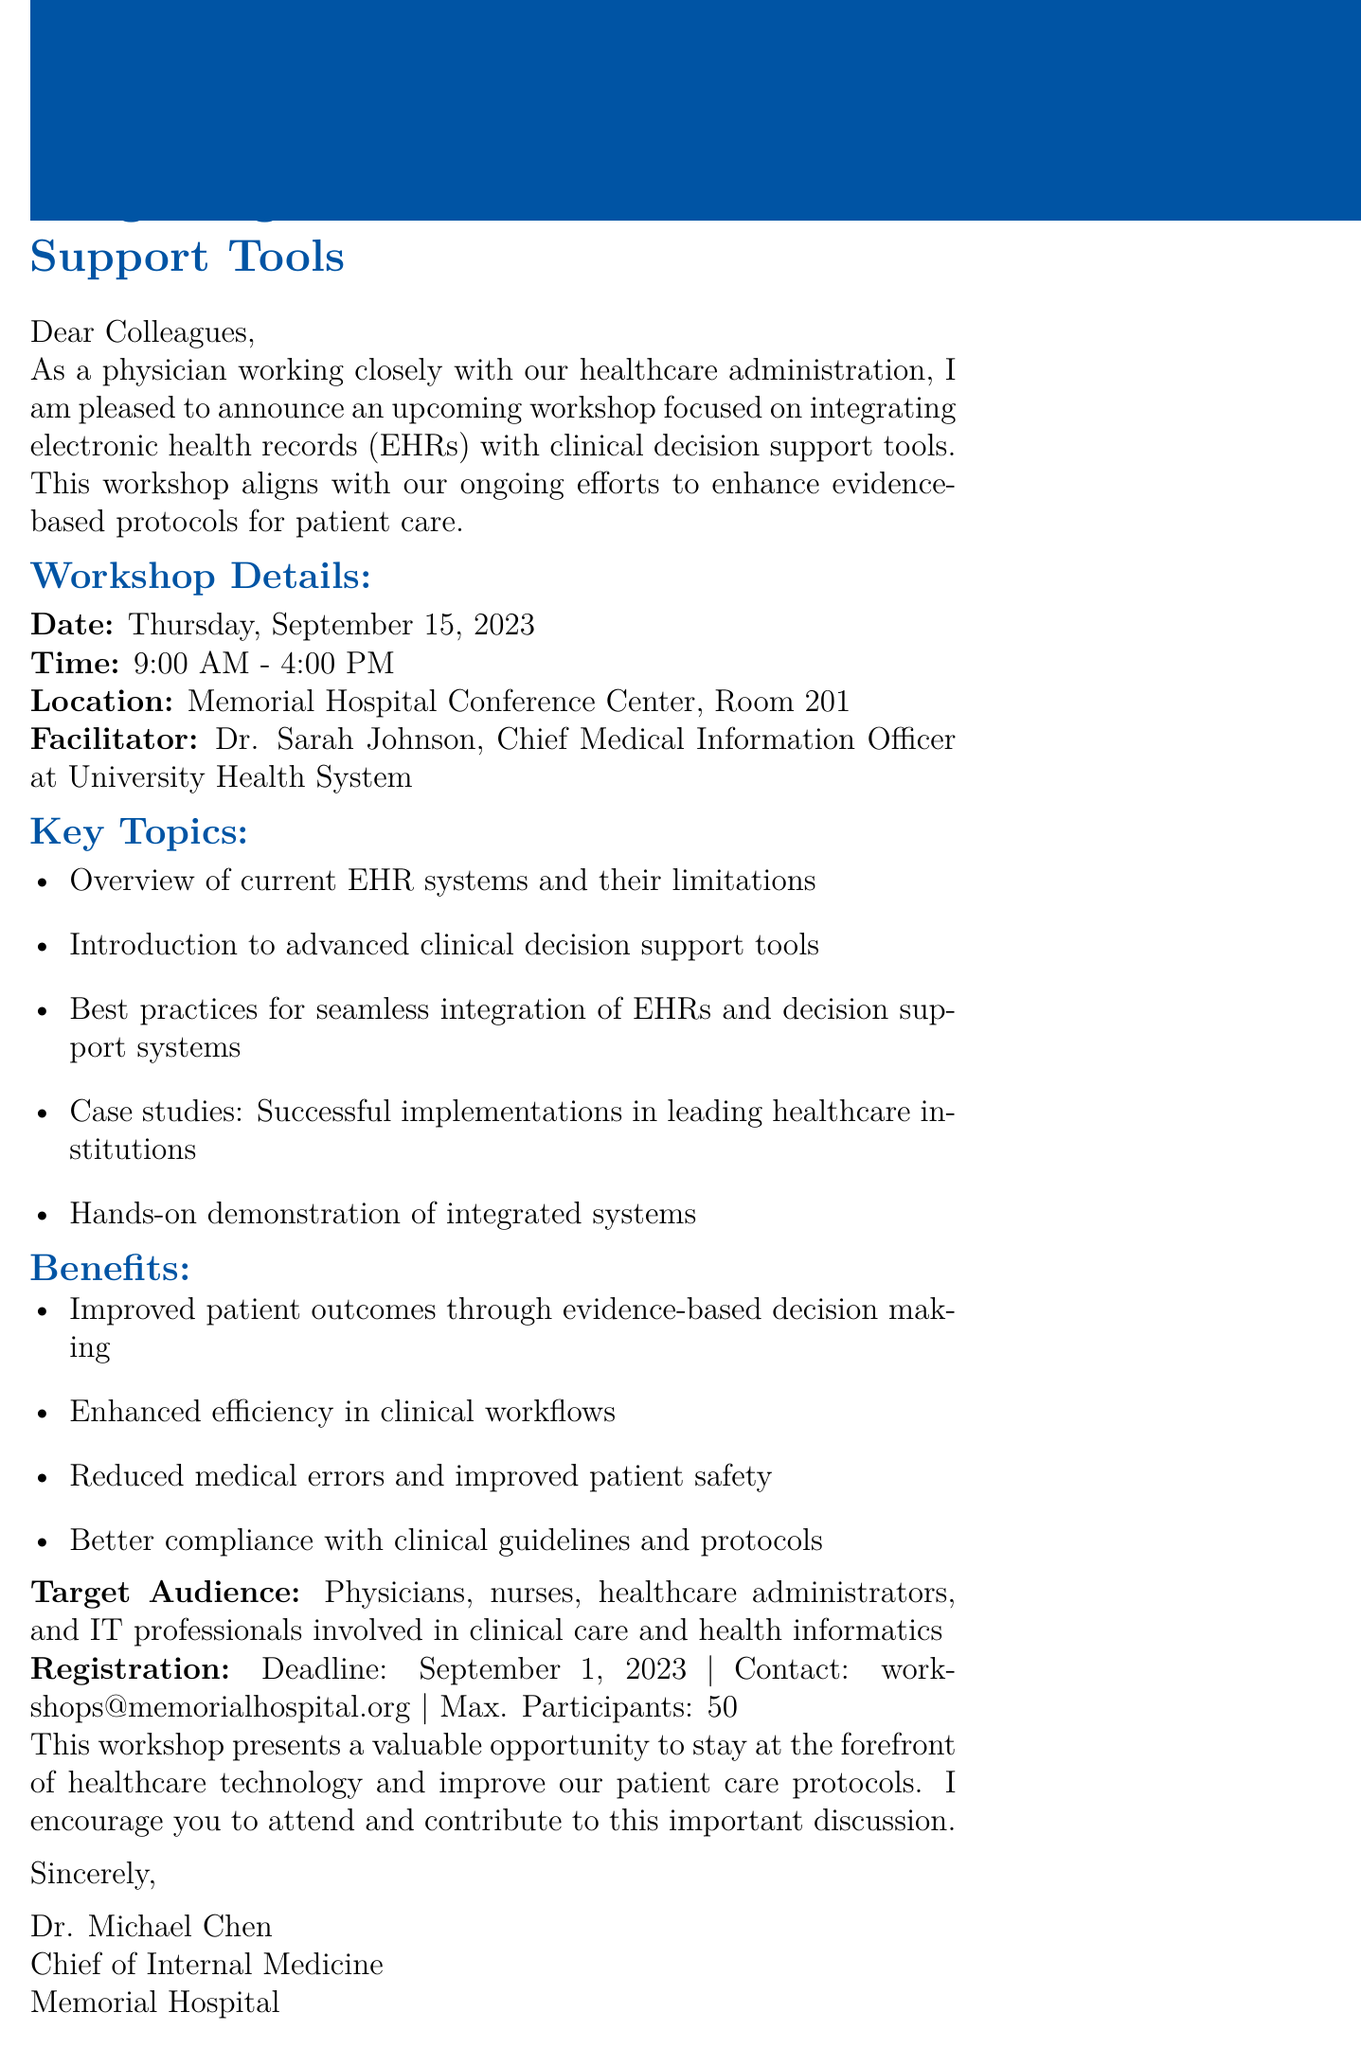What is the date of the workshop? The document specifies that the workshop will take place on Thursday, September 15, 2023.
Answer: Thursday, September 15, 2023 Who is the facilitator of the workshop? The document mentions that Dr. Sarah Johnson will be the facilitator of the workshop.
Answer: Dr. Sarah Johnson What is the maximum number of participants for the workshop? The document states that the maximum number of participants is limited to 50.
Answer: 50 What is one key topic covered in the workshop? The document lists several key topics, one of which is an overview of current EHR systems and their limitations.
Answer: Overview of current EHR systems and their limitations What is the registration deadline for the workshop? The document indicates that the registration deadline is September 1, 2023.
Answer: September 1, 2023 Who is the author of the announcement? The document identifies Dr. Michael Chen as the author of the announcement.
Answer: Dr. Michael Chen What benefits are highlighted for attending the workshop? The document mentions several benefits, including improved patient outcomes through evidence-based decision making.
Answer: Improved patient outcomes through evidence-based decision making What is the location of the workshop? The document specifies that the workshop will be held at the Memorial Hospital Conference Center, Room 201.
Answer: Memorial Hospital Conference Center, Room 201 